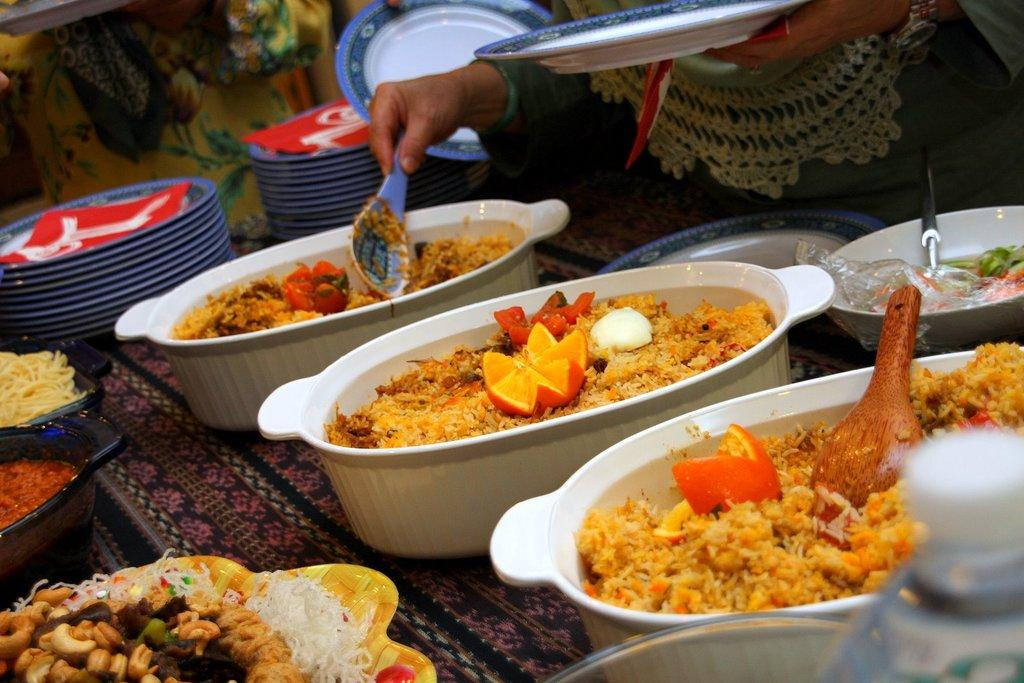What is the person holding in the image? The person is holding a plate and a spoon. What can be seen on the surface in the image? There are bowls and plates on the surface. What is inside the bowls? There are food items in the bowls. Can you see a pig in the image? No, there is no pig present in the image. 